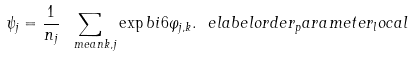<formula> <loc_0><loc_0><loc_500><loc_500>\psi _ { j } = \frac { 1 } { n _ { j } } \sum _ { \ m e a n { k , j } } \exp b { i 6 \varphi _ { j , k } } . \ e l a b e l { o r d e r _ { p } a r a m e t e r _ { l } o c a l }</formula> 